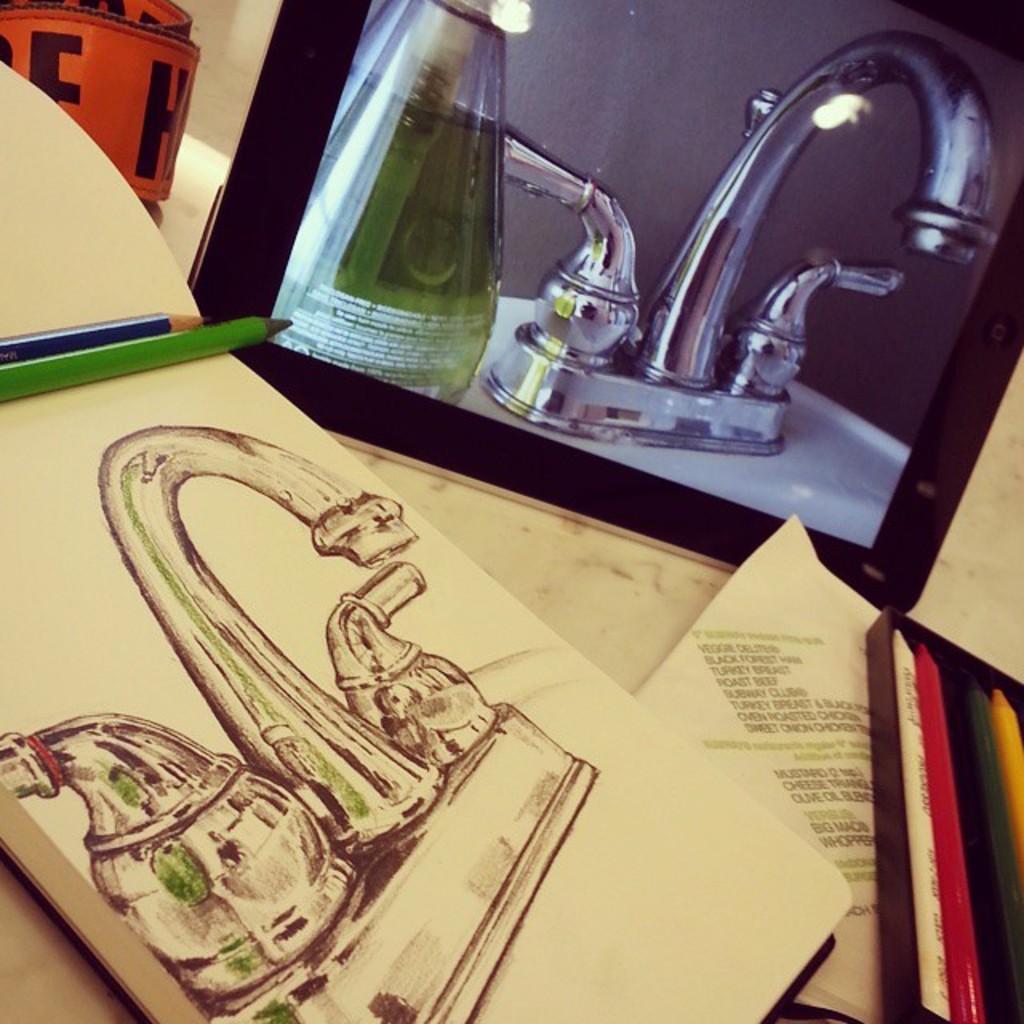Could you give a brief overview of what you see in this image? In this image I can see a book, pencils, paper, a box and some other objects are placed on a white surface. Along with these things there is a device and on the screen I can see a bottle and a tap. 